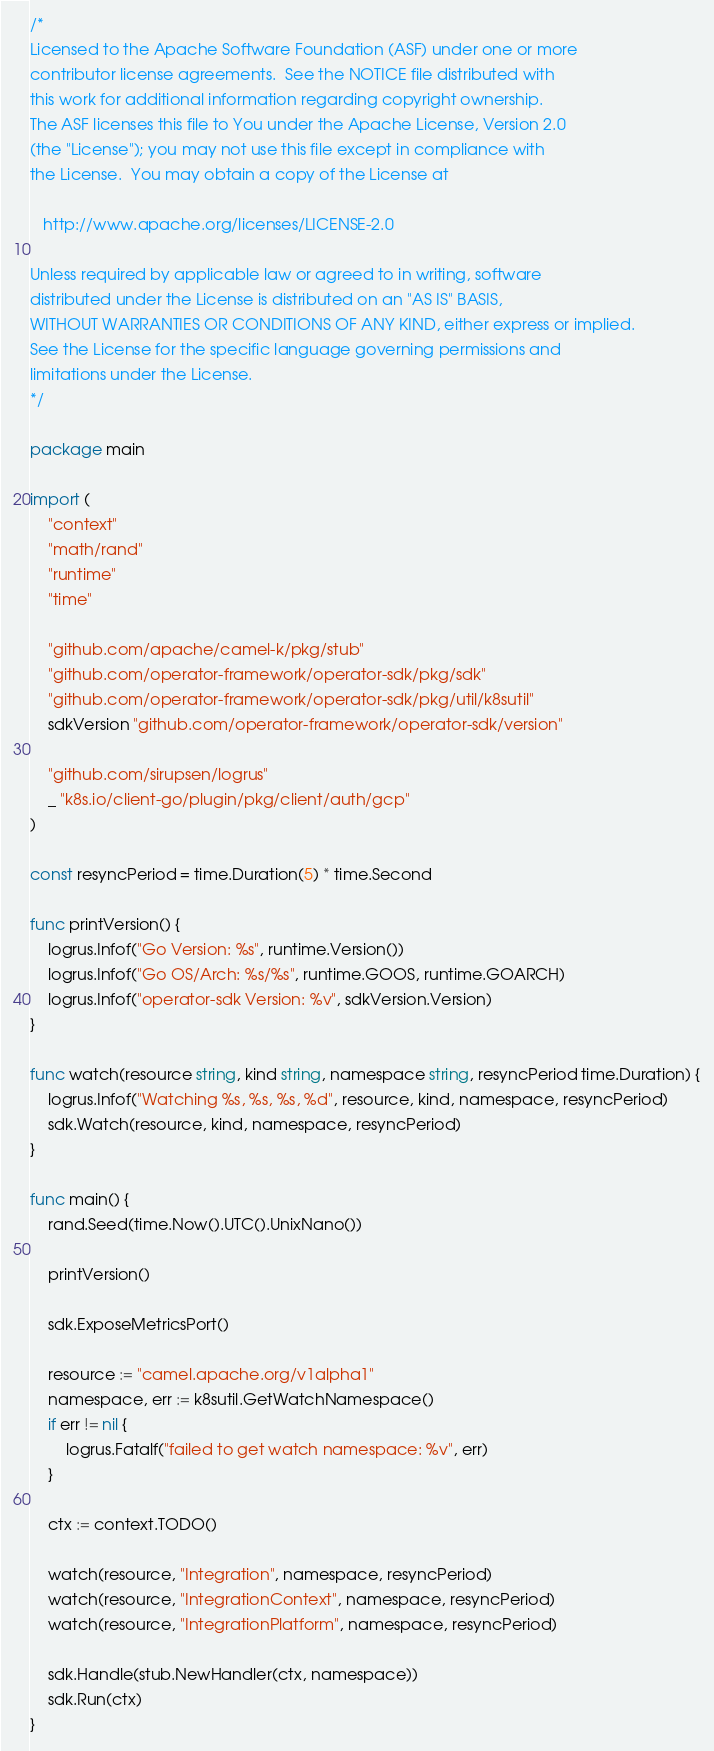<code> <loc_0><loc_0><loc_500><loc_500><_Go_>/*
Licensed to the Apache Software Foundation (ASF) under one or more
contributor license agreements.  See the NOTICE file distributed with
this work for additional information regarding copyright ownership.
The ASF licenses this file to You under the Apache License, Version 2.0
(the "License"); you may not use this file except in compliance with
the License.  You may obtain a copy of the License at

   http://www.apache.org/licenses/LICENSE-2.0

Unless required by applicable law or agreed to in writing, software
distributed under the License is distributed on an "AS IS" BASIS,
WITHOUT WARRANTIES OR CONDITIONS OF ANY KIND, either express or implied.
See the License for the specific language governing permissions and
limitations under the License.
*/

package main

import (
	"context"
	"math/rand"
	"runtime"
	"time"

	"github.com/apache/camel-k/pkg/stub"
	"github.com/operator-framework/operator-sdk/pkg/sdk"
	"github.com/operator-framework/operator-sdk/pkg/util/k8sutil"
	sdkVersion "github.com/operator-framework/operator-sdk/version"

	"github.com/sirupsen/logrus"
	_ "k8s.io/client-go/plugin/pkg/client/auth/gcp"
)

const resyncPeriod = time.Duration(5) * time.Second

func printVersion() {
	logrus.Infof("Go Version: %s", runtime.Version())
	logrus.Infof("Go OS/Arch: %s/%s", runtime.GOOS, runtime.GOARCH)
	logrus.Infof("operator-sdk Version: %v", sdkVersion.Version)
}

func watch(resource string, kind string, namespace string, resyncPeriod time.Duration) {
	logrus.Infof("Watching %s, %s, %s, %d", resource, kind, namespace, resyncPeriod)
	sdk.Watch(resource, kind, namespace, resyncPeriod)
}

func main() {
	rand.Seed(time.Now().UTC().UnixNano())

	printVersion()

	sdk.ExposeMetricsPort()

	resource := "camel.apache.org/v1alpha1"
	namespace, err := k8sutil.GetWatchNamespace()
	if err != nil {
		logrus.Fatalf("failed to get watch namespace: %v", err)
	}

	ctx := context.TODO()

	watch(resource, "Integration", namespace, resyncPeriod)
	watch(resource, "IntegrationContext", namespace, resyncPeriod)
	watch(resource, "IntegrationPlatform", namespace, resyncPeriod)

	sdk.Handle(stub.NewHandler(ctx, namespace))
	sdk.Run(ctx)
}
</code> 